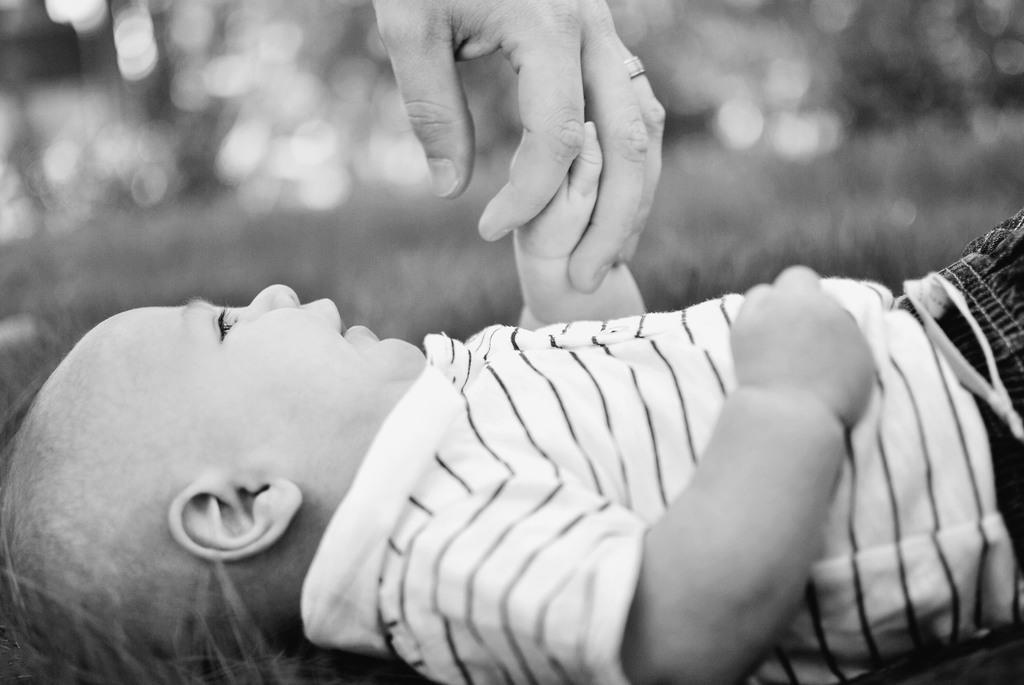Who is the main subject in the image? There is a boy in the image. What is the boy doing in the image? The boy is laying on the ground and smiling. Is the boy interacting with anyone in the image? Yes, the boy is holding the hand of another person. Can you describe the background of the image? The background of the image is blurry. Where is the nest of the guide in the image? There is no nest or guide present in the image; it features a boy laying on the ground and smiling. How many dolls are visible in the image? There are no dolls present in the image. 